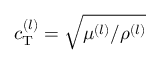<formula> <loc_0><loc_0><loc_500><loc_500>c _ { T } ^ { ( l ) } = \sqrt { \mu ^ { ( l ) } / \rho ^ { ( l ) } }</formula> 